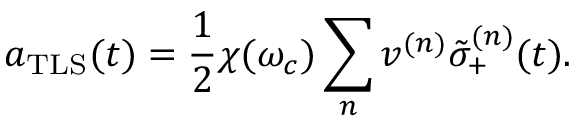Convert formula to latex. <formula><loc_0><loc_0><loc_500><loc_500>a _ { T L S } ( t ) = \frac { 1 } { 2 } \chi ( \omega _ { c } ) \sum _ { n } v ^ { ( n ) } \tilde { \sigma } _ { + } ^ { ( n ) } ( t ) .</formula> 